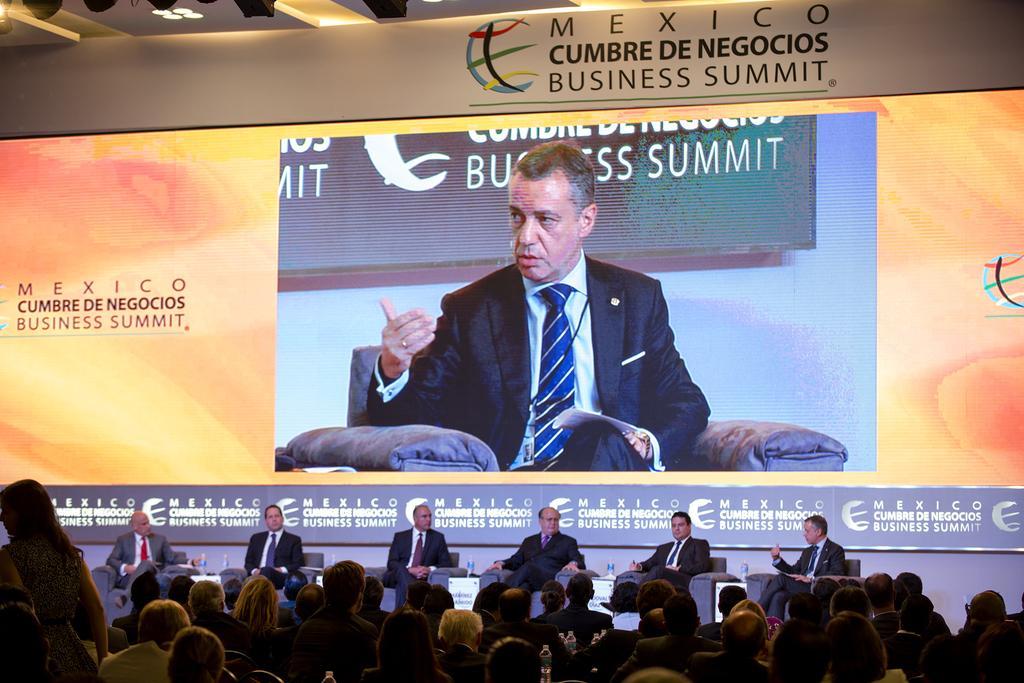How would you summarize this image in a sentence or two? At the top of the image we can see a display and a man sitting in the couch on it. At the bottom of the image we can see some persons sitting in the couches on the dais and spectators. 